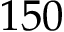Convert formula to latex. <formula><loc_0><loc_0><loc_500><loc_500>1 5 0</formula> 